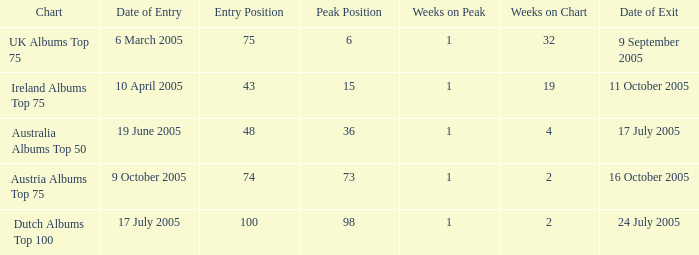What is the leaving date for the dutch albums top 100 chart? 24 July 2005. 